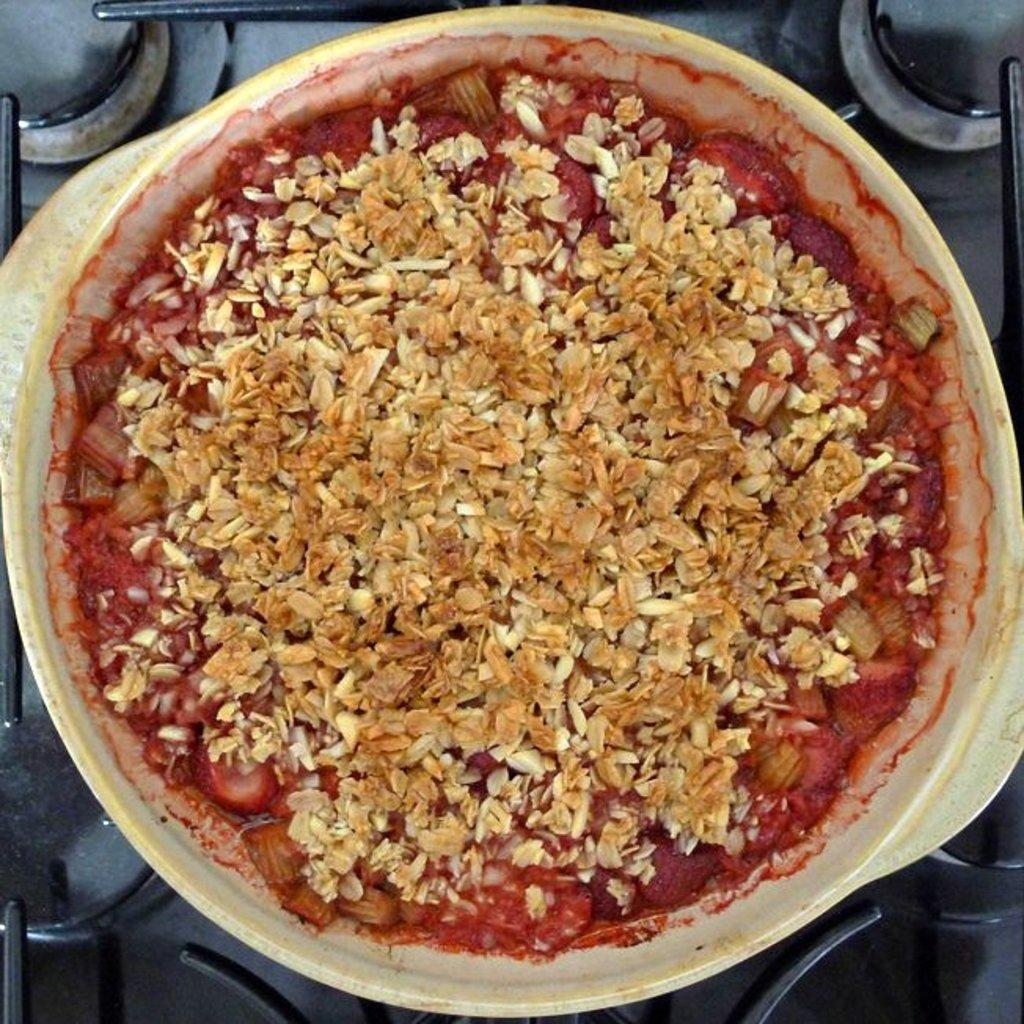What is inside the container that is visible in the image? There is food in a container in the image. What can be seen in the background of the image? There is a stand in the background of the image. What type of shirt is being worn by the ocean in the image? There is no ocean present in the image, and therefore no shirt can be associated with it. 